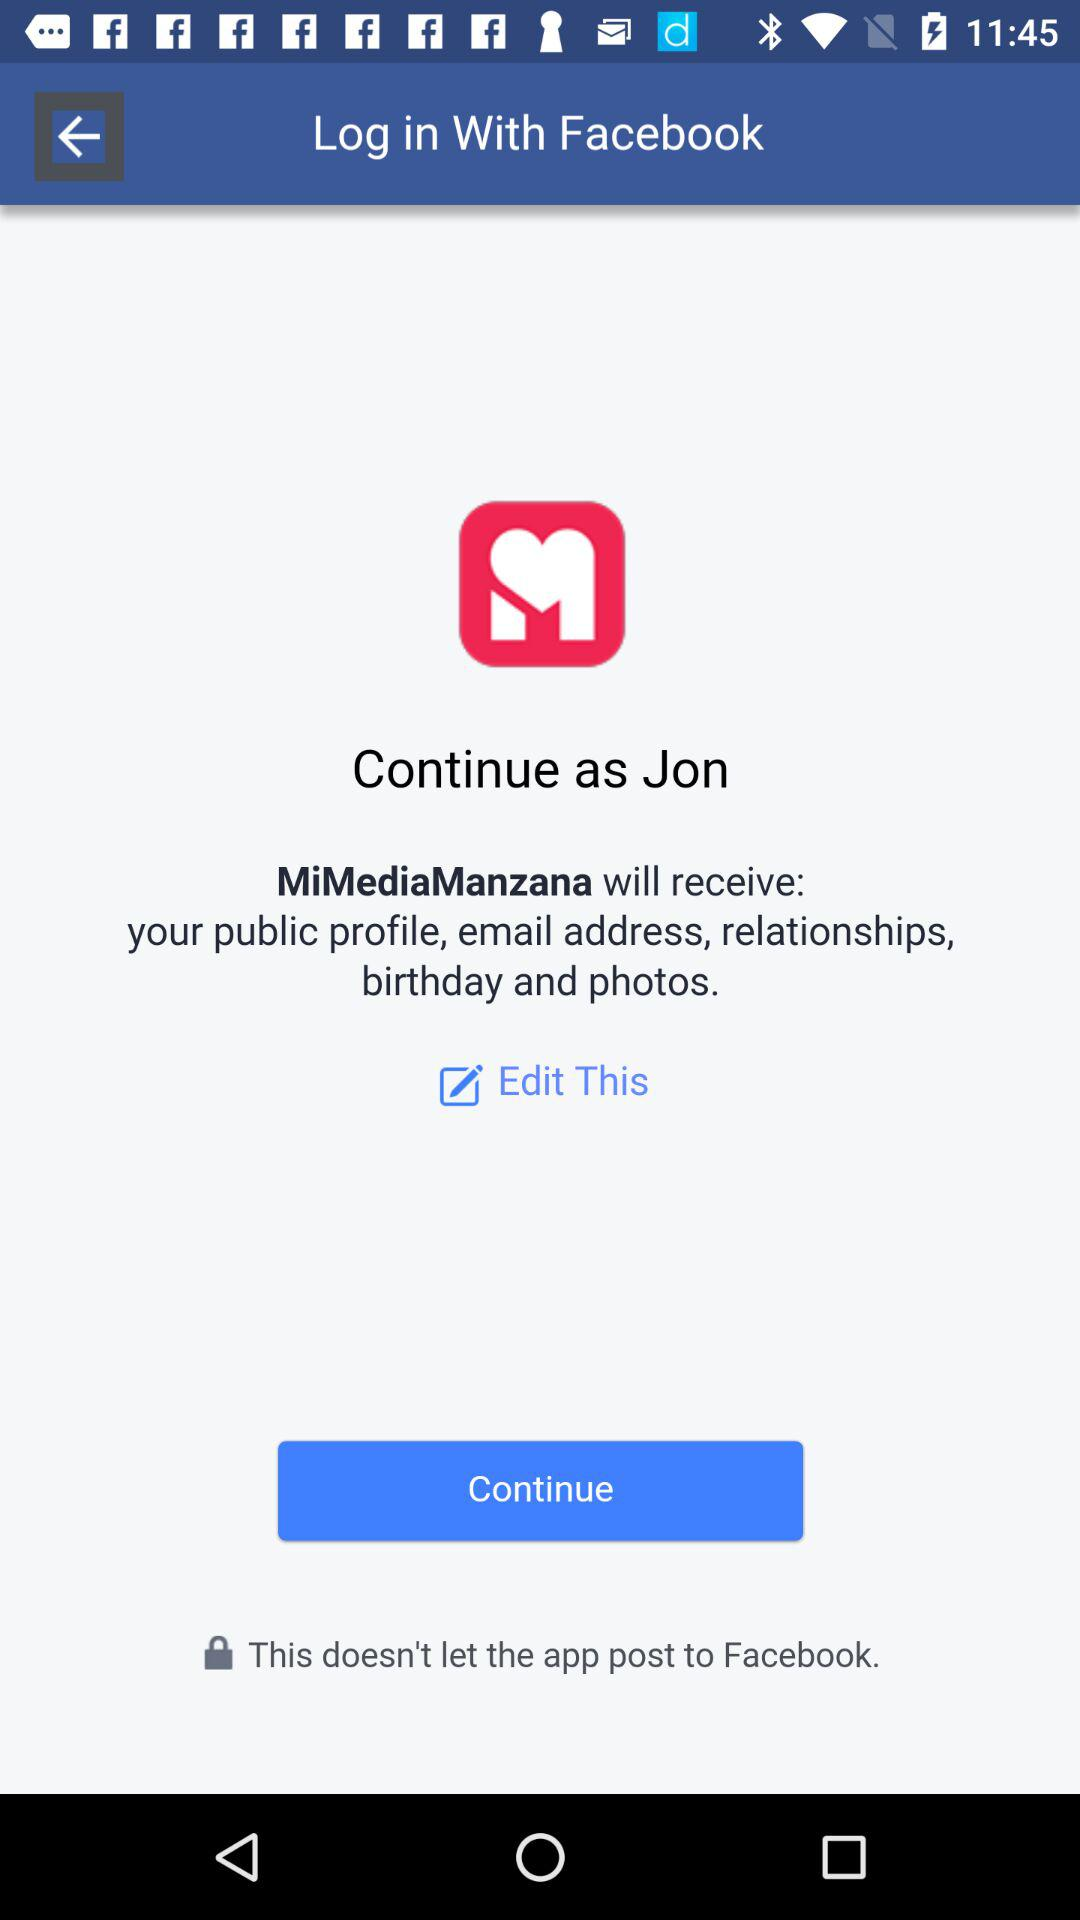What application is asking for permission? The application that is asking for permission is "MiMediaManzana". 